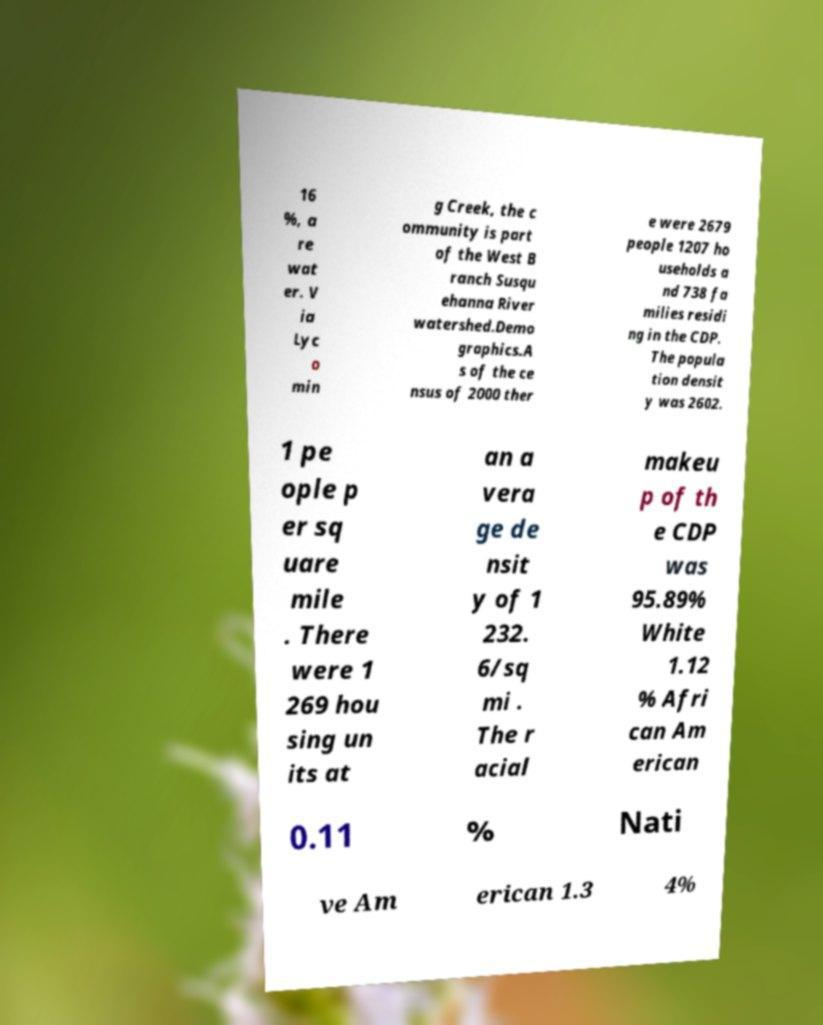Can you read and provide the text displayed in the image?This photo seems to have some interesting text. Can you extract and type it out for me? 16 %, a re wat er. V ia Lyc o min g Creek, the c ommunity is part of the West B ranch Susqu ehanna River watershed.Demo graphics.A s of the ce nsus of 2000 ther e were 2679 people 1207 ho useholds a nd 738 fa milies residi ng in the CDP. The popula tion densit y was 2602. 1 pe ople p er sq uare mile . There were 1 269 hou sing un its at an a vera ge de nsit y of 1 232. 6/sq mi . The r acial makeu p of th e CDP was 95.89% White 1.12 % Afri can Am erican 0.11 % Nati ve Am erican 1.3 4% 